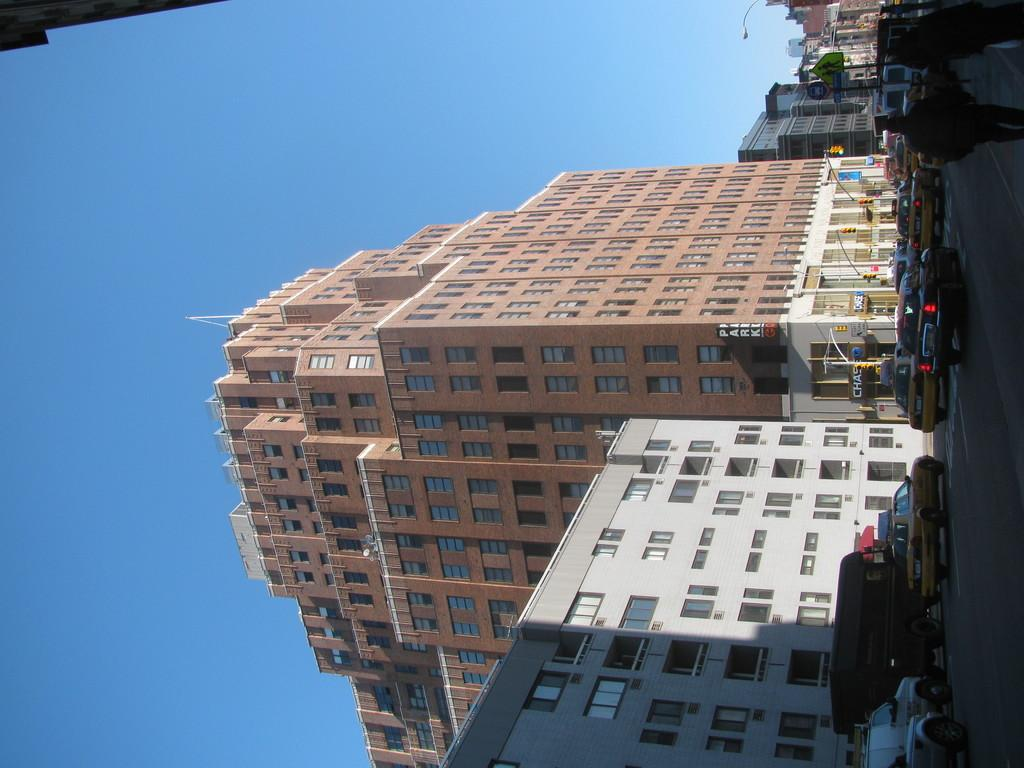What can be seen on the right side of the image? There is a road on the right side of the image. What is happening on the road? Cars are present on the road. Are there any people visible in the image? Yes, there are people walking in the image. What is located in the center of the image? There are buildings in the center of the image. What is visible in the background of the image? The sky is visible in the background of the image. What type of throat-soothing remedy is being offered in the image? There is no throat-soothing remedy present in the image. What religion is being practiced in the image? There is no indication of any religious practice in the image. 